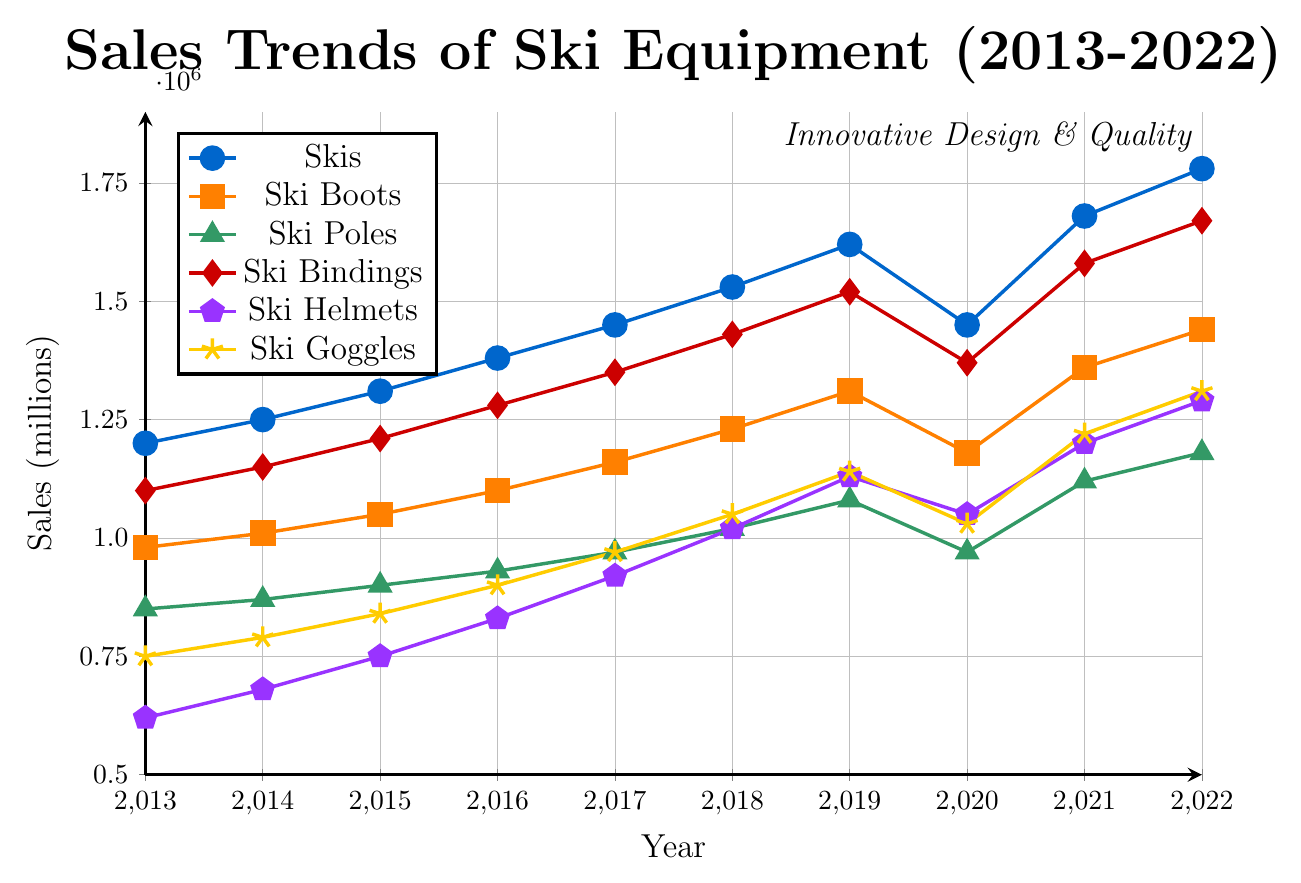Which year had the highest sales for skis? By observing the line representing skis, the highest point is at 2022.
Answer: 2022 How do the sales of ski helmets in 2018 compare to the sales in 2013? The sales for ski helmets in 2013 were 620,000, and in 2018 they were 1,020,000. Comparing these values, sales in 2018 are significantly higher.
Answer: 2018 had higher sales What was the average annual sales of ski helmets between 2013 and 2022? To find the average, sum all sales values for ski helmets (620,000 + 680,000 + 750,000 + 830,000 + 920,000 + 1,020,000 + 1,130,000 + 1,050,000 + 1,200,000 + 1,290,000) and divide by the number of years (10). The total sales are 9,490,000. Dividing by 10 gives the average: 949,000.
Answer: 949,000 Which category had the smallest decline in sales in 2020 compared to 2019? By comparing the sales values for each category between 2019 and 2020:
- Skis: 1.62M to 1.45M (decline of 0.17M)
- Ski Boots: 1.31M to 1.18M (decline of 0.13M)
- Ski Poles: 1.08M to 0.97M (decline of 0.11M)
- Ski Bindings: 1.52M to 1.37M (decline of 0.15M)
- Ski Helmets: 1.13M to 1.05M (decline of 0.08M)
- Ski Goggles: 1.14M to 1.03M (decline of 0.11M)
Based on these values, ski helmets had the smallest decline.
Answer: Ski Helmets In which year did the sales of ski bindings surpass 1.5 million? By tracing the line for ski bindings, the sales value surpasses 1.5 million in 2019.
Answer: 2019 Which year saw a dip in ski goggles sales, breaking the upward trend? The line representing ski goggles shows a dip in 2020.
Answer: 2020 What were the sales of ski goggles in 2022 and how does it compare to sales in 2013? The sales of ski goggles in 2013 were 750,000, and in 2022, they were 1,310,000. Comparing these, sales in 2022 were much higher.
Answer: 2022 had higher sales If you sum the sales of ski poles in 2014, 2016, and 2018, what is the result? The sales values are 870,000 (2014), 930,000 (2016), and 1,020,000 (2018). Summing these: 870,000 + 930,000 + 1,020,000 = 2,820,000.
Answer: 2,820,000 Which category showed consistent growth every year without any decline? By observing the trends for each category, ski bindings is the category which showed consistent growth every year.
Answer: Ski Bindings 